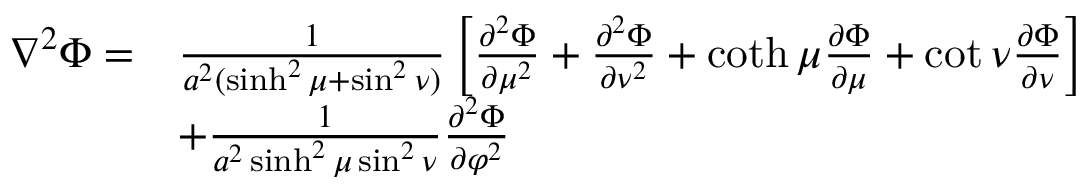Convert formula to latex. <formula><loc_0><loc_0><loc_500><loc_500>{ \begin{array} { r l } { \nabla ^ { 2 } \Phi = } & { { \frac { 1 } { a ^ { 2 } ( \sinh ^ { 2 } \mu + \sin ^ { 2 } \nu ) } } \left [ { \frac { \partial ^ { 2 } \Phi } { \partial \mu ^ { 2 } } } + { \frac { \partial ^ { 2 } \Phi } { \partial \nu ^ { 2 } } } + \coth \mu { \frac { \partial \Phi } { \partial \mu } } + \cot \nu { \frac { \partial \Phi } { \partial \nu } } \right ] } \\ & { + { \frac { 1 } { a ^ { 2 } \sinh ^ { 2 } \mu \sin ^ { 2 } \nu } } { \frac { \partial ^ { 2 } \Phi } { \partial \varphi ^ { 2 } } } } \end{array} }</formula> 